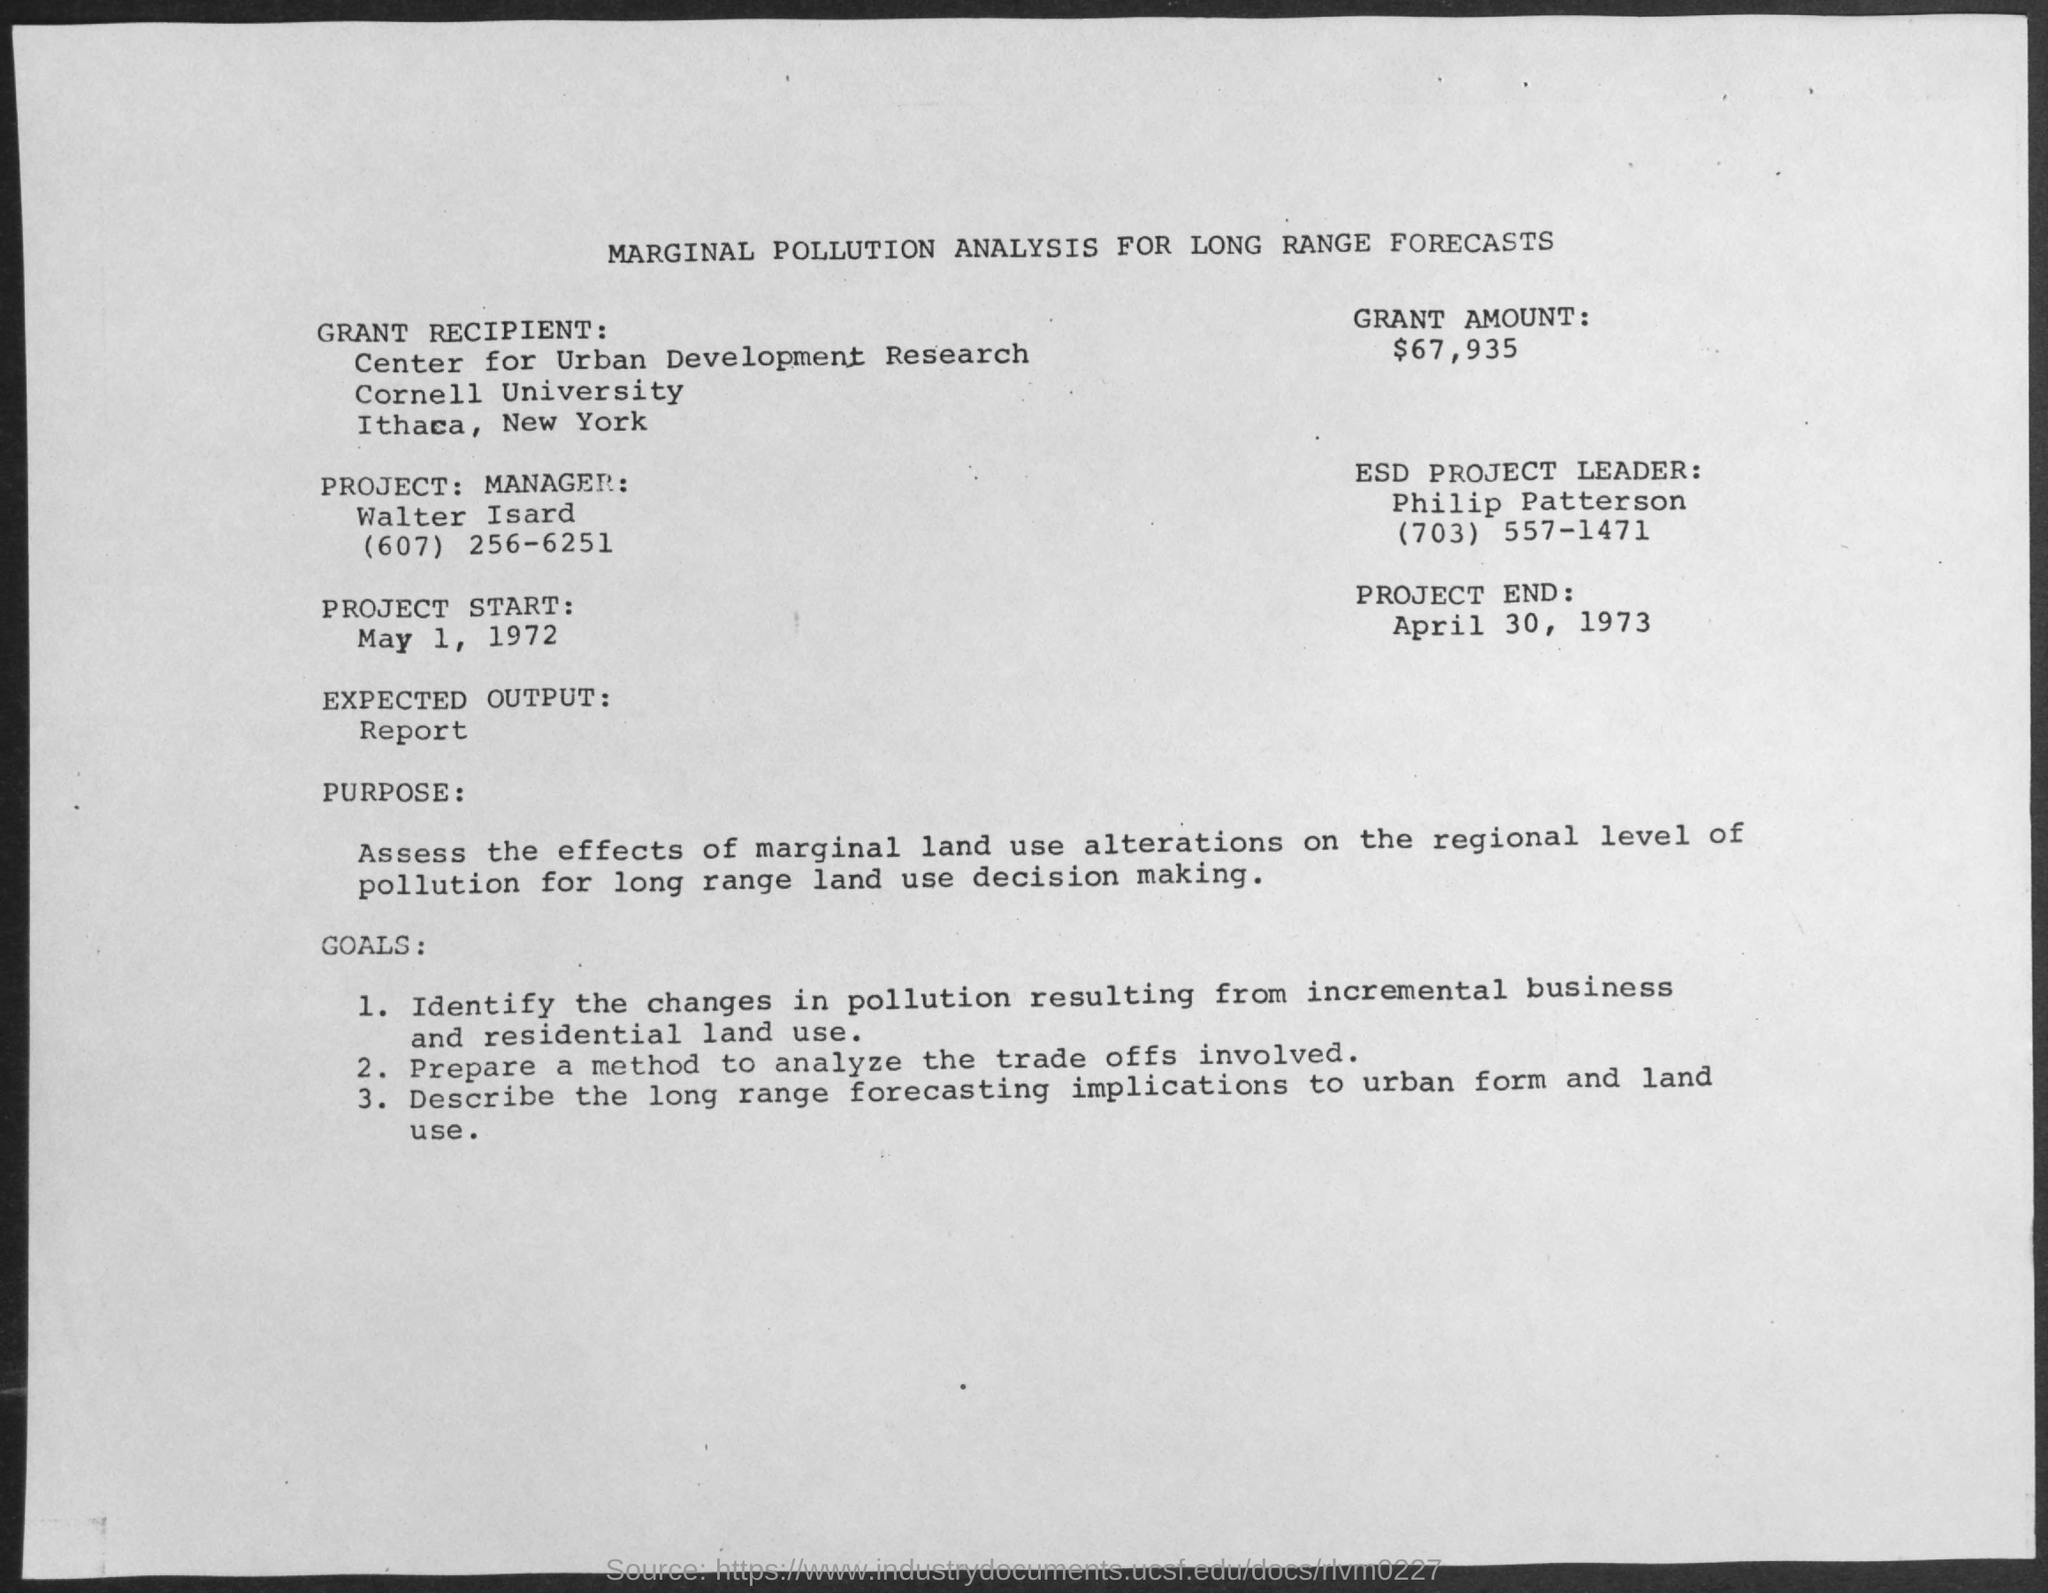What is the date of project end?
Offer a terse response. April 30, 1973. Who is project manager?
Make the answer very short. Walter Isard. What is the date of the project start ?
Make the answer very short. May 1 , 1972. What is the name of the esd project leader ?
Provide a succinct answer. Philip Patterson. What is the value of the grant amount ?
Offer a very short reply. $67,935. What is the expected output given in the analysis ?
Provide a short and direct response. Report. What is the name of the university mentioned in the grant recipient ?
Make the answer very short. Cornell university. 